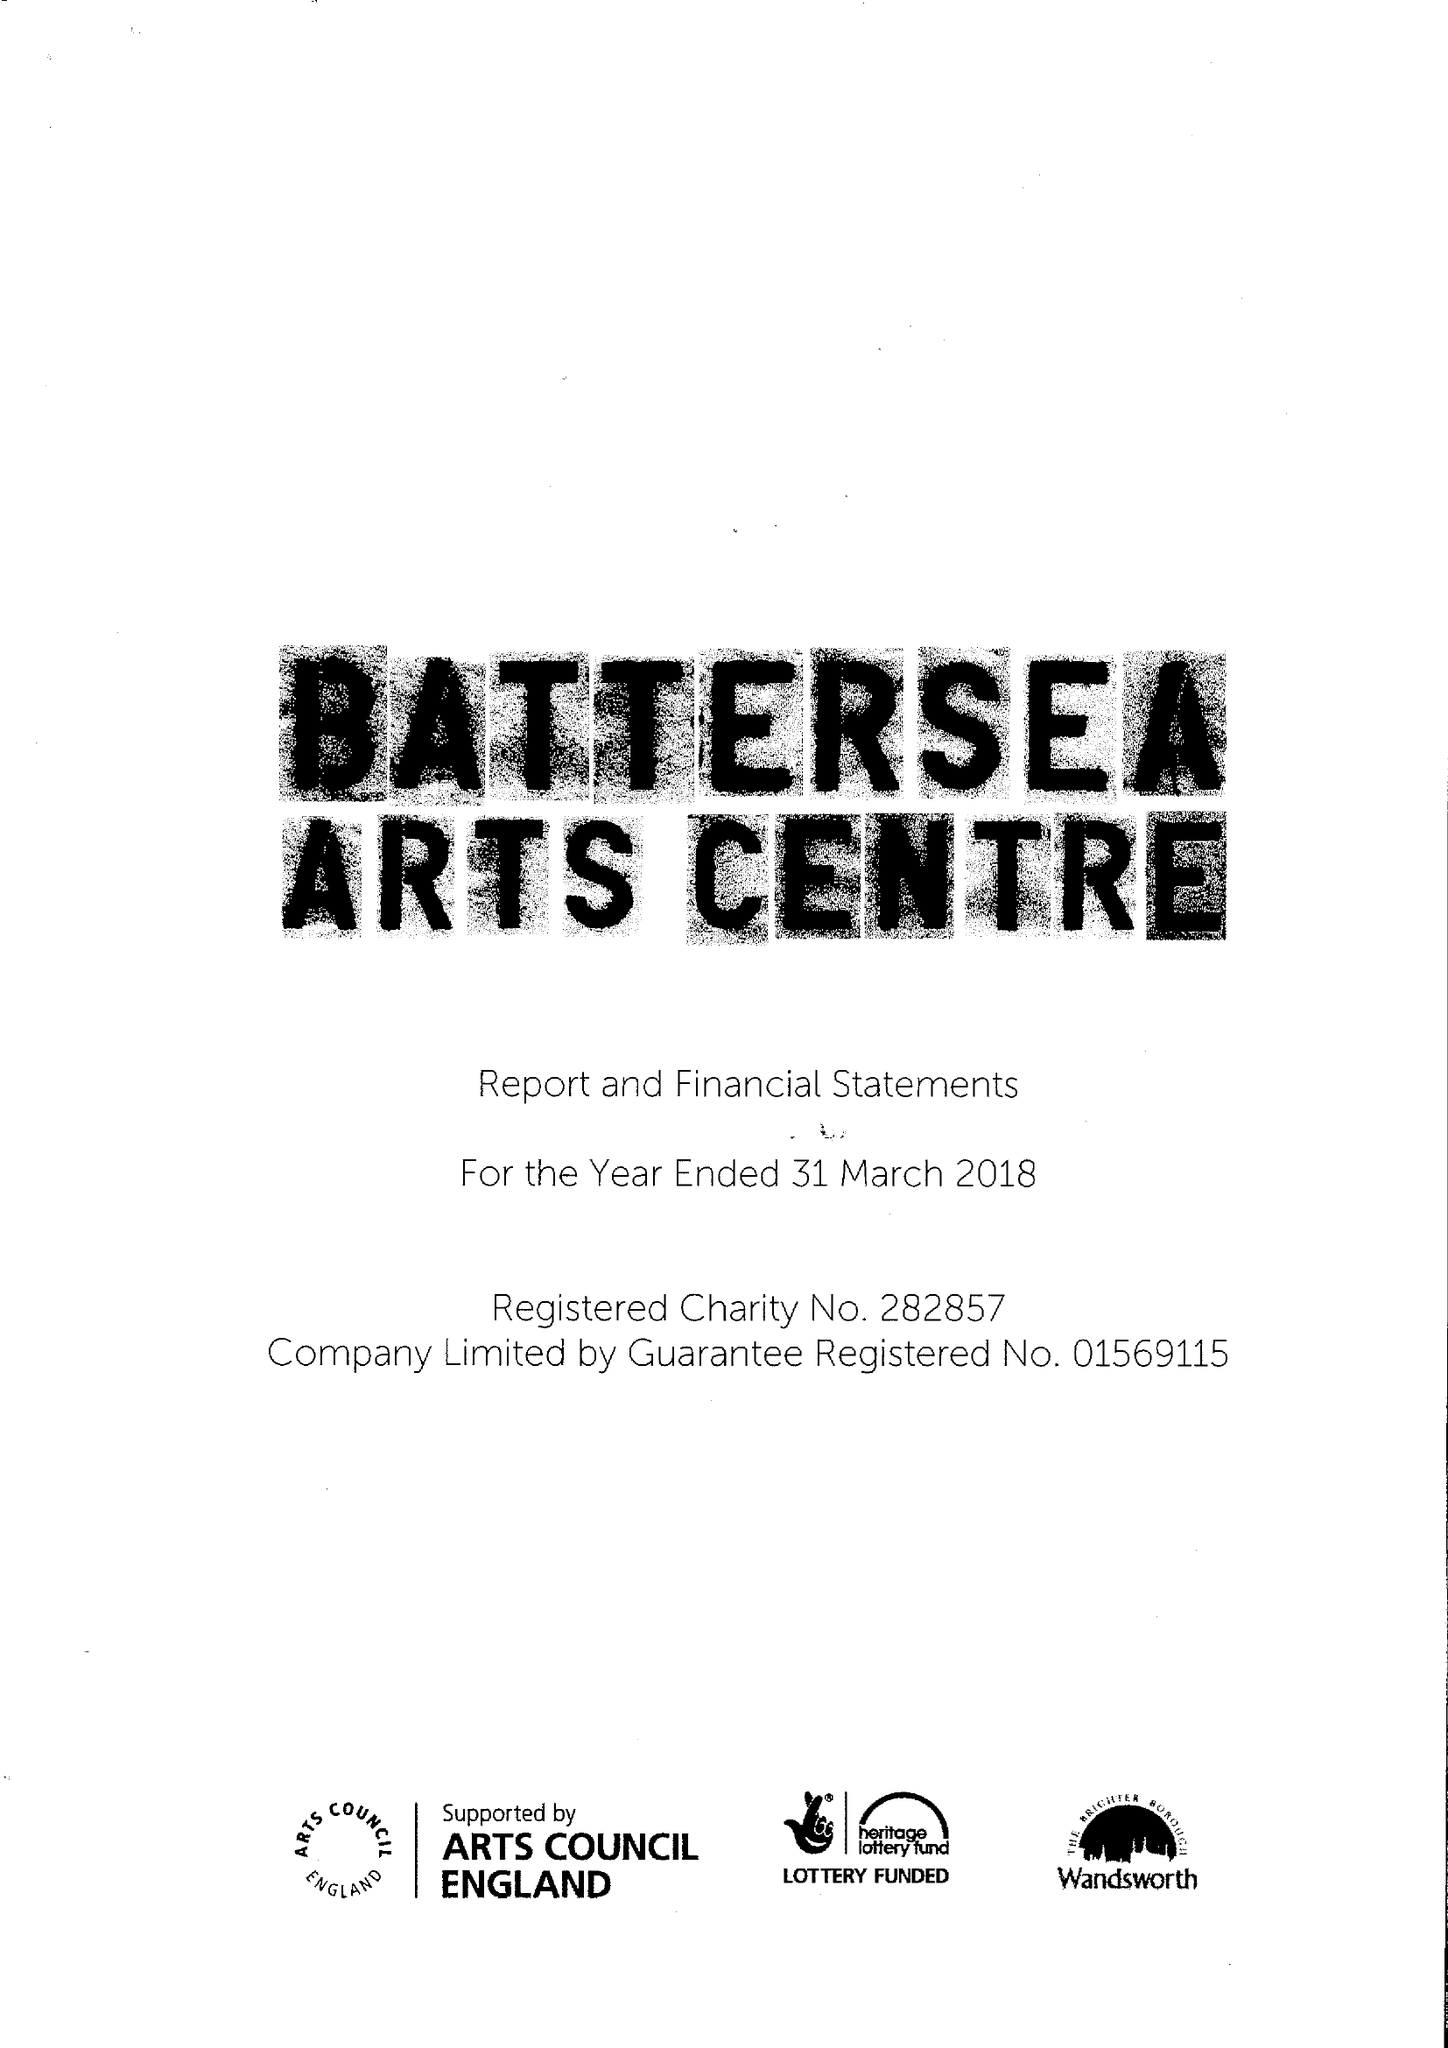What is the value for the report_date?
Answer the question using a single word or phrase. 2018-03-31 